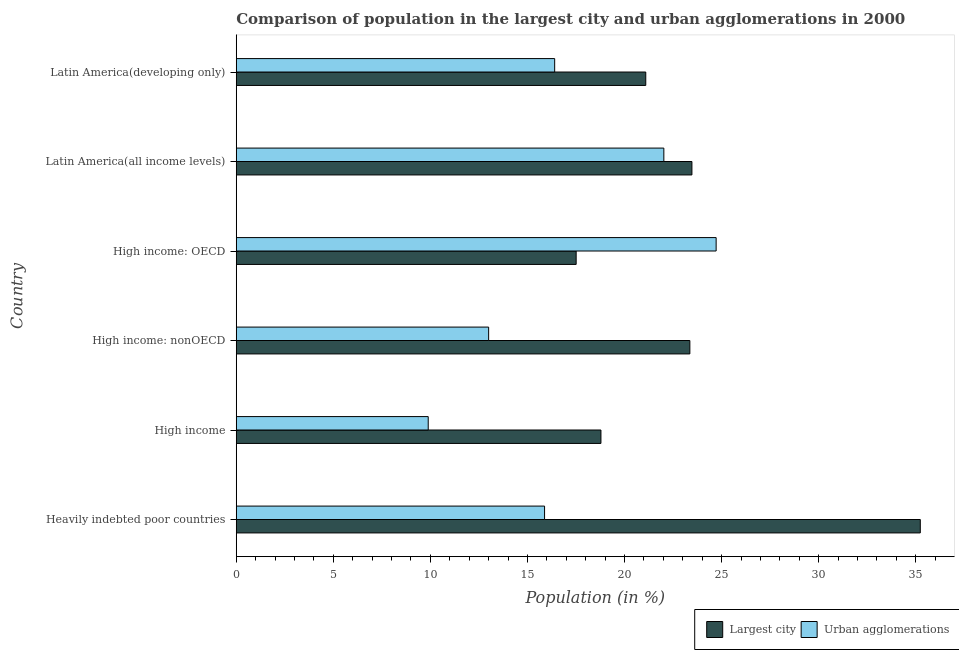How many different coloured bars are there?
Give a very brief answer. 2. How many groups of bars are there?
Make the answer very short. 6. How many bars are there on the 4th tick from the bottom?
Give a very brief answer. 2. What is the label of the 6th group of bars from the top?
Make the answer very short. Heavily indebted poor countries. What is the population in urban agglomerations in High income: OECD?
Provide a short and direct response. 24.72. Across all countries, what is the maximum population in the largest city?
Ensure brevity in your answer.  35.23. Across all countries, what is the minimum population in the largest city?
Provide a short and direct response. 17.51. In which country was the population in urban agglomerations maximum?
Provide a succinct answer. High income: OECD. In which country was the population in urban agglomerations minimum?
Your response must be concise. High income. What is the total population in the largest city in the graph?
Offer a terse response. 139.45. What is the difference between the population in the largest city in Latin America(all income levels) and that in Latin America(developing only)?
Your answer should be very brief. 2.38. What is the difference between the population in urban agglomerations in High income and the population in the largest city in High income: nonOECD?
Ensure brevity in your answer.  -13.48. What is the average population in the largest city per country?
Provide a succinct answer. 23.24. What is the difference between the population in the largest city and population in urban agglomerations in Latin America(all income levels)?
Make the answer very short. 1.45. What is the ratio of the population in urban agglomerations in High income: nonOECD to that in Latin America(all income levels)?
Offer a terse response. 0.59. Is the population in urban agglomerations in High income: OECD less than that in Latin America(all income levels)?
Your answer should be compact. No. Is the difference between the population in urban agglomerations in Heavily indebted poor countries and Latin America(developing only) greater than the difference between the population in the largest city in Heavily indebted poor countries and Latin America(developing only)?
Make the answer very short. No. What is the difference between the highest and the second highest population in urban agglomerations?
Provide a short and direct response. 2.69. What is the difference between the highest and the lowest population in the largest city?
Offer a terse response. 17.73. In how many countries, is the population in urban agglomerations greater than the average population in urban agglomerations taken over all countries?
Offer a terse response. 2. What does the 1st bar from the top in Latin America(all income levels) represents?
Provide a short and direct response. Urban agglomerations. What does the 1st bar from the bottom in High income: nonOECD represents?
Offer a very short reply. Largest city. Are all the bars in the graph horizontal?
Your response must be concise. Yes. How many countries are there in the graph?
Offer a terse response. 6. Where does the legend appear in the graph?
Give a very brief answer. Bottom right. How many legend labels are there?
Ensure brevity in your answer.  2. What is the title of the graph?
Ensure brevity in your answer.  Comparison of population in the largest city and urban agglomerations in 2000. What is the label or title of the Y-axis?
Offer a very short reply. Country. What is the Population (in %) of Largest city in Heavily indebted poor countries?
Keep it short and to the point. 35.23. What is the Population (in %) in Urban agglomerations in Heavily indebted poor countries?
Offer a terse response. 15.88. What is the Population (in %) in Largest city in High income?
Offer a terse response. 18.78. What is the Population (in %) of Urban agglomerations in High income?
Offer a very short reply. 9.89. What is the Population (in %) of Largest city in High income: nonOECD?
Your answer should be compact. 23.36. What is the Population (in %) of Urban agglomerations in High income: nonOECD?
Offer a very short reply. 13. What is the Population (in %) of Largest city in High income: OECD?
Your response must be concise. 17.51. What is the Population (in %) in Urban agglomerations in High income: OECD?
Give a very brief answer. 24.72. What is the Population (in %) of Largest city in Latin America(all income levels)?
Keep it short and to the point. 23.47. What is the Population (in %) in Urban agglomerations in Latin America(all income levels)?
Your response must be concise. 22.02. What is the Population (in %) in Largest city in Latin America(developing only)?
Offer a terse response. 21.09. What is the Population (in %) in Urban agglomerations in Latin America(developing only)?
Offer a very short reply. 16.4. Across all countries, what is the maximum Population (in %) in Largest city?
Ensure brevity in your answer.  35.23. Across all countries, what is the maximum Population (in %) in Urban agglomerations?
Ensure brevity in your answer.  24.72. Across all countries, what is the minimum Population (in %) of Largest city?
Provide a succinct answer. 17.51. Across all countries, what is the minimum Population (in %) of Urban agglomerations?
Provide a short and direct response. 9.89. What is the total Population (in %) in Largest city in the graph?
Ensure brevity in your answer.  139.45. What is the total Population (in %) of Urban agglomerations in the graph?
Your response must be concise. 101.91. What is the difference between the Population (in %) of Largest city in Heavily indebted poor countries and that in High income?
Offer a terse response. 16.45. What is the difference between the Population (in %) of Urban agglomerations in Heavily indebted poor countries and that in High income?
Your answer should be very brief. 5.99. What is the difference between the Population (in %) in Largest city in Heavily indebted poor countries and that in High income: nonOECD?
Your response must be concise. 11.87. What is the difference between the Population (in %) of Urban agglomerations in Heavily indebted poor countries and that in High income: nonOECD?
Provide a succinct answer. 2.88. What is the difference between the Population (in %) in Largest city in Heavily indebted poor countries and that in High income: OECD?
Provide a short and direct response. 17.73. What is the difference between the Population (in %) in Urban agglomerations in Heavily indebted poor countries and that in High income: OECD?
Make the answer very short. -8.84. What is the difference between the Population (in %) of Largest city in Heavily indebted poor countries and that in Latin America(all income levels)?
Offer a very short reply. 11.76. What is the difference between the Population (in %) of Urban agglomerations in Heavily indebted poor countries and that in Latin America(all income levels)?
Ensure brevity in your answer.  -6.14. What is the difference between the Population (in %) of Largest city in Heavily indebted poor countries and that in Latin America(developing only)?
Your answer should be compact. 14.14. What is the difference between the Population (in %) in Urban agglomerations in Heavily indebted poor countries and that in Latin America(developing only)?
Give a very brief answer. -0.52. What is the difference between the Population (in %) in Largest city in High income and that in High income: nonOECD?
Ensure brevity in your answer.  -4.58. What is the difference between the Population (in %) in Urban agglomerations in High income and that in High income: nonOECD?
Give a very brief answer. -3.11. What is the difference between the Population (in %) of Largest city in High income and that in High income: OECD?
Provide a short and direct response. 1.28. What is the difference between the Population (in %) in Urban agglomerations in High income and that in High income: OECD?
Provide a short and direct response. -14.83. What is the difference between the Population (in %) of Largest city in High income and that in Latin America(all income levels)?
Make the answer very short. -4.69. What is the difference between the Population (in %) in Urban agglomerations in High income and that in Latin America(all income levels)?
Offer a terse response. -12.14. What is the difference between the Population (in %) in Largest city in High income and that in Latin America(developing only)?
Keep it short and to the point. -2.31. What is the difference between the Population (in %) of Urban agglomerations in High income and that in Latin America(developing only)?
Your answer should be very brief. -6.51. What is the difference between the Population (in %) of Largest city in High income: nonOECD and that in High income: OECD?
Provide a short and direct response. 5.86. What is the difference between the Population (in %) in Urban agglomerations in High income: nonOECD and that in High income: OECD?
Make the answer very short. -11.72. What is the difference between the Population (in %) in Largest city in High income: nonOECD and that in Latin America(all income levels)?
Ensure brevity in your answer.  -0.11. What is the difference between the Population (in %) in Urban agglomerations in High income: nonOECD and that in Latin America(all income levels)?
Your answer should be very brief. -9.02. What is the difference between the Population (in %) in Largest city in High income: nonOECD and that in Latin America(developing only)?
Your response must be concise. 2.27. What is the difference between the Population (in %) of Urban agglomerations in High income: nonOECD and that in Latin America(developing only)?
Offer a very short reply. -3.4. What is the difference between the Population (in %) in Largest city in High income: OECD and that in Latin America(all income levels)?
Ensure brevity in your answer.  -5.96. What is the difference between the Population (in %) of Urban agglomerations in High income: OECD and that in Latin America(all income levels)?
Give a very brief answer. 2.69. What is the difference between the Population (in %) in Largest city in High income: OECD and that in Latin America(developing only)?
Keep it short and to the point. -3.59. What is the difference between the Population (in %) of Urban agglomerations in High income: OECD and that in Latin America(developing only)?
Provide a succinct answer. 8.32. What is the difference between the Population (in %) of Largest city in Latin America(all income levels) and that in Latin America(developing only)?
Your answer should be compact. 2.38. What is the difference between the Population (in %) in Urban agglomerations in Latin America(all income levels) and that in Latin America(developing only)?
Give a very brief answer. 5.62. What is the difference between the Population (in %) of Largest city in Heavily indebted poor countries and the Population (in %) of Urban agglomerations in High income?
Offer a very short reply. 25.34. What is the difference between the Population (in %) in Largest city in Heavily indebted poor countries and the Population (in %) in Urban agglomerations in High income: nonOECD?
Give a very brief answer. 22.23. What is the difference between the Population (in %) of Largest city in Heavily indebted poor countries and the Population (in %) of Urban agglomerations in High income: OECD?
Ensure brevity in your answer.  10.52. What is the difference between the Population (in %) in Largest city in Heavily indebted poor countries and the Population (in %) in Urban agglomerations in Latin America(all income levels)?
Offer a terse response. 13.21. What is the difference between the Population (in %) in Largest city in Heavily indebted poor countries and the Population (in %) in Urban agglomerations in Latin America(developing only)?
Your answer should be very brief. 18.83. What is the difference between the Population (in %) of Largest city in High income and the Population (in %) of Urban agglomerations in High income: nonOECD?
Provide a short and direct response. 5.78. What is the difference between the Population (in %) in Largest city in High income and the Population (in %) in Urban agglomerations in High income: OECD?
Ensure brevity in your answer.  -5.93. What is the difference between the Population (in %) in Largest city in High income and the Population (in %) in Urban agglomerations in Latin America(all income levels)?
Your answer should be very brief. -3.24. What is the difference between the Population (in %) in Largest city in High income and the Population (in %) in Urban agglomerations in Latin America(developing only)?
Your answer should be compact. 2.38. What is the difference between the Population (in %) of Largest city in High income: nonOECD and the Population (in %) of Urban agglomerations in High income: OECD?
Your response must be concise. -1.35. What is the difference between the Population (in %) in Largest city in High income: nonOECD and the Population (in %) in Urban agglomerations in Latin America(all income levels)?
Provide a short and direct response. 1.34. What is the difference between the Population (in %) of Largest city in High income: nonOECD and the Population (in %) of Urban agglomerations in Latin America(developing only)?
Provide a short and direct response. 6.96. What is the difference between the Population (in %) of Largest city in High income: OECD and the Population (in %) of Urban agglomerations in Latin America(all income levels)?
Offer a very short reply. -4.52. What is the difference between the Population (in %) of Largest city in High income: OECD and the Population (in %) of Urban agglomerations in Latin America(developing only)?
Ensure brevity in your answer.  1.11. What is the difference between the Population (in %) of Largest city in Latin America(all income levels) and the Population (in %) of Urban agglomerations in Latin America(developing only)?
Provide a short and direct response. 7.07. What is the average Population (in %) in Largest city per country?
Make the answer very short. 23.24. What is the average Population (in %) of Urban agglomerations per country?
Your answer should be compact. 16.98. What is the difference between the Population (in %) in Largest city and Population (in %) in Urban agglomerations in Heavily indebted poor countries?
Provide a short and direct response. 19.35. What is the difference between the Population (in %) in Largest city and Population (in %) in Urban agglomerations in High income?
Offer a very short reply. 8.9. What is the difference between the Population (in %) in Largest city and Population (in %) in Urban agglomerations in High income: nonOECD?
Offer a very short reply. 10.36. What is the difference between the Population (in %) of Largest city and Population (in %) of Urban agglomerations in High income: OECD?
Provide a succinct answer. -7.21. What is the difference between the Population (in %) of Largest city and Population (in %) of Urban agglomerations in Latin America(all income levels)?
Provide a short and direct response. 1.45. What is the difference between the Population (in %) of Largest city and Population (in %) of Urban agglomerations in Latin America(developing only)?
Keep it short and to the point. 4.69. What is the ratio of the Population (in %) of Largest city in Heavily indebted poor countries to that in High income?
Your answer should be very brief. 1.88. What is the ratio of the Population (in %) of Urban agglomerations in Heavily indebted poor countries to that in High income?
Offer a very short reply. 1.61. What is the ratio of the Population (in %) of Largest city in Heavily indebted poor countries to that in High income: nonOECD?
Offer a terse response. 1.51. What is the ratio of the Population (in %) in Urban agglomerations in Heavily indebted poor countries to that in High income: nonOECD?
Give a very brief answer. 1.22. What is the ratio of the Population (in %) of Largest city in Heavily indebted poor countries to that in High income: OECD?
Ensure brevity in your answer.  2.01. What is the ratio of the Population (in %) of Urban agglomerations in Heavily indebted poor countries to that in High income: OECD?
Offer a terse response. 0.64. What is the ratio of the Population (in %) in Largest city in Heavily indebted poor countries to that in Latin America(all income levels)?
Your response must be concise. 1.5. What is the ratio of the Population (in %) in Urban agglomerations in Heavily indebted poor countries to that in Latin America(all income levels)?
Your answer should be compact. 0.72. What is the ratio of the Population (in %) of Largest city in Heavily indebted poor countries to that in Latin America(developing only)?
Offer a terse response. 1.67. What is the ratio of the Population (in %) of Urban agglomerations in Heavily indebted poor countries to that in Latin America(developing only)?
Offer a terse response. 0.97. What is the ratio of the Population (in %) in Largest city in High income to that in High income: nonOECD?
Your answer should be compact. 0.8. What is the ratio of the Population (in %) in Urban agglomerations in High income to that in High income: nonOECD?
Provide a short and direct response. 0.76. What is the ratio of the Population (in %) in Largest city in High income to that in High income: OECD?
Offer a very short reply. 1.07. What is the ratio of the Population (in %) of Largest city in High income to that in Latin America(all income levels)?
Your answer should be very brief. 0.8. What is the ratio of the Population (in %) of Urban agglomerations in High income to that in Latin America(all income levels)?
Offer a very short reply. 0.45. What is the ratio of the Population (in %) in Largest city in High income to that in Latin America(developing only)?
Your answer should be compact. 0.89. What is the ratio of the Population (in %) in Urban agglomerations in High income to that in Latin America(developing only)?
Offer a very short reply. 0.6. What is the ratio of the Population (in %) in Largest city in High income: nonOECD to that in High income: OECD?
Make the answer very short. 1.33. What is the ratio of the Population (in %) in Urban agglomerations in High income: nonOECD to that in High income: OECD?
Make the answer very short. 0.53. What is the ratio of the Population (in %) in Urban agglomerations in High income: nonOECD to that in Latin America(all income levels)?
Ensure brevity in your answer.  0.59. What is the ratio of the Population (in %) in Largest city in High income: nonOECD to that in Latin America(developing only)?
Make the answer very short. 1.11. What is the ratio of the Population (in %) in Urban agglomerations in High income: nonOECD to that in Latin America(developing only)?
Give a very brief answer. 0.79. What is the ratio of the Population (in %) in Largest city in High income: OECD to that in Latin America(all income levels)?
Provide a short and direct response. 0.75. What is the ratio of the Population (in %) in Urban agglomerations in High income: OECD to that in Latin America(all income levels)?
Offer a terse response. 1.12. What is the ratio of the Population (in %) of Largest city in High income: OECD to that in Latin America(developing only)?
Give a very brief answer. 0.83. What is the ratio of the Population (in %) of Urban agglomerations in High income: OECD to that in Latin America(developing only)?
Keep it short and to the point. 1.51. What is the ratio of the Population (in %) in Largest city in Latin America(all income levels) to that in Latin America(developing only)?
Your answer should be compact. 1.11. What is the ratio of the Population (in %) of Urban agglomerations in Latin America(all income levels) to that in Latin America(developing only)?
Your response must be concise. 1.34. What is the difference between the highest and the second highest Population (in %) in Largest city?
Offer a very short reply. 11.76. What is the difference between the highest and the second highest Population (in %) of Urban agglomerations?
Give a very brief answer. 2.69. What is the difference between the highest and the lowest Population (in %) of Largest city?
Provide a succinct answer. 17.73. What is the difference between the highest and the lowest Population (in %) in Urban agglomerations?
Offer a very short reply. 14.83. 